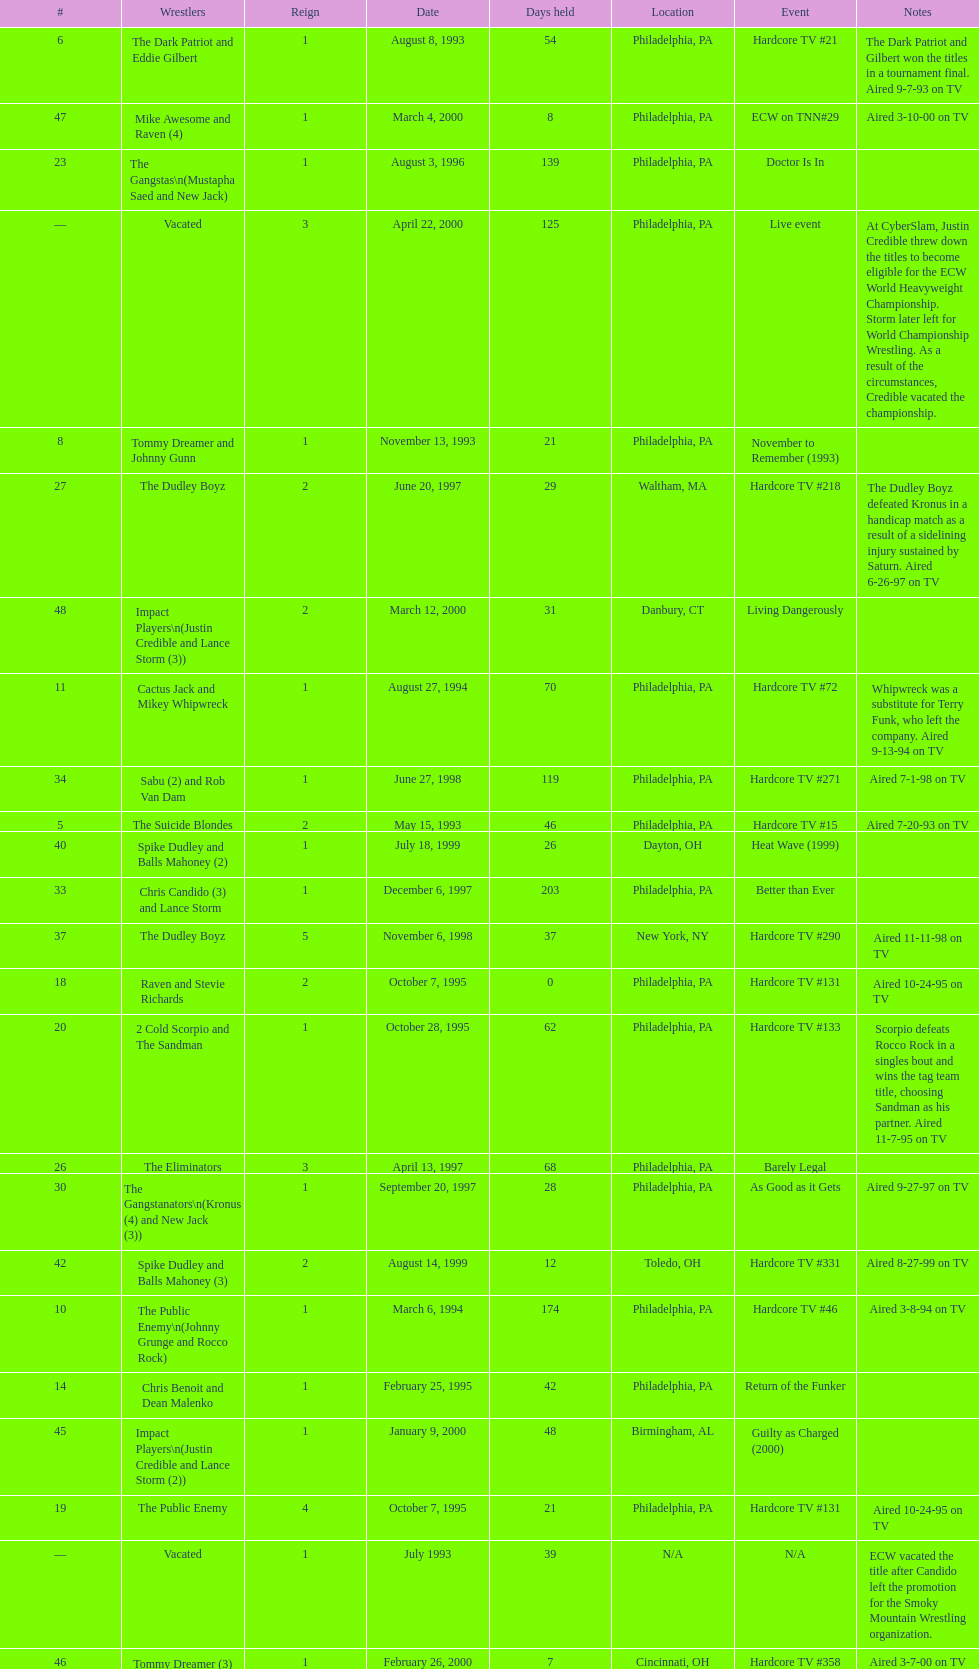Which was the only team to win by forfeit? The Dudley Boyz. 